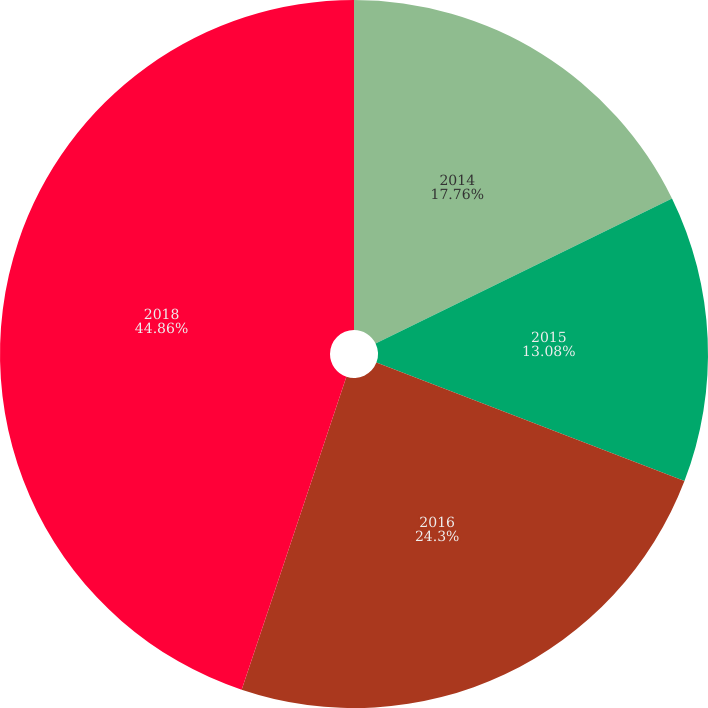Convert chart. <chart><loc_0><loc_0><loc_500><loc_500><pie_chart><fcel>2014<fcel>2015<fcel>2016<fcel>2018<nl><fcel>17.76%<fcel>13.08%<fcel>24.3%<fcel>44.86%<nl></chart> 